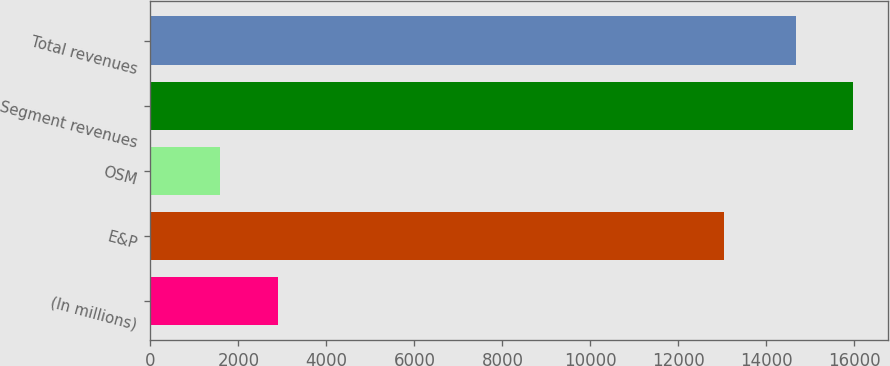Convert chart to OTSL. <chart><loc_0><loc_0><loc_500><loc_500><bar_chart><fcel>(In millions)<fcel>E&P<fcel>OSM<fcel>Segment revenues<fcel>Total revenues<nl><fcel>2900.2<fcel>13029<fcel>1588<fcel>15975.2<fcel>14663<nl></chart> 